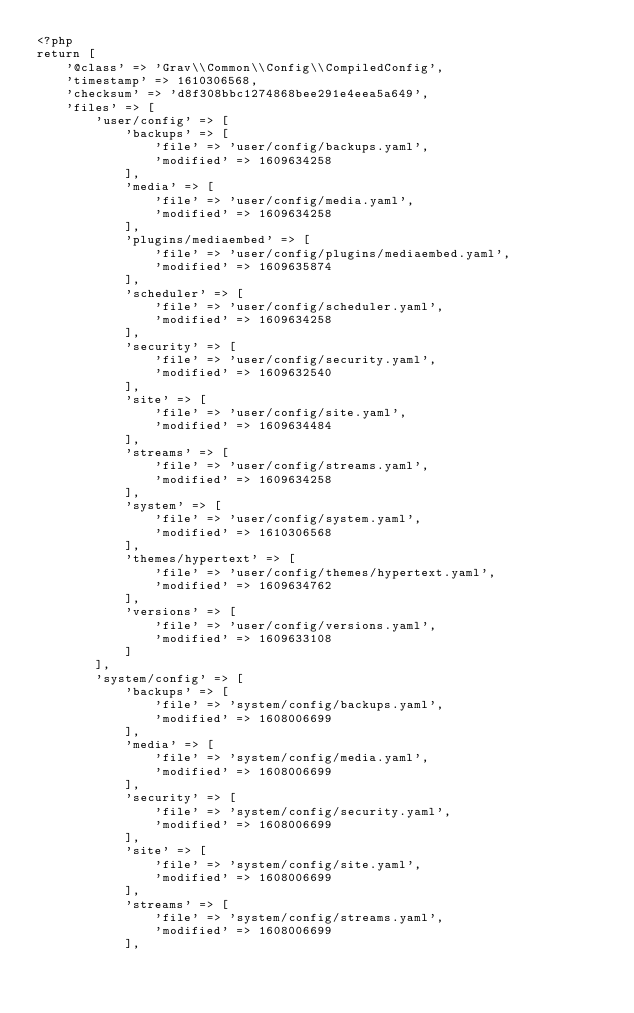Convert code to text. <code><loc_0><loc_0><loc_500><loc_500><_PHP_><?php
return [
    '@class' => 'Grav\\Common\\Config\\CompiledConfig',
    'timestamp' => 1610306568,
    'checksum' => 'd8f308bbc1274868bee291e4eea5a649',
    'files' => [
        'user/config' => [
            'backups' => [
                'file' => 'user/config/backups.yaml',
                'modified' => 1609634258
            ],
            'media' => [
                'file' => 'user/config/media.yaml',
                'modified' => 1609634258
            ],
            'plugins/mediaembed' => [
                'file' => 'user/config/plugins/mediaembed.yaml',
                'modified' => 1609635874
            ],
            'scheduler' => [
                'file' => 'user/config/scheduler.yaml',
                'modified' => 1609634258
            ],
            'security' => [
                'file' => 'user/config/security.yaml',
                'modified' => 1609632540
            ],
            'site' => [
                'file' => 'user/config/site.yaml',
                'modified' => 1609634484
            ],
            'streams' => [
                'file' => 'user/config/streams.yaml',
                'modified' => 1609634258
            ],
            'system' => [
                'file' => 'user/config/system.yaml',
                'modified' => 1610306568
            ],
            'themes/hypertext' => [
                'file' => 'user/config/themes/hypertext.yaml',
                'modified' => 1609634762
            ],
            'versions' => [
                'file' => 'user/config/versions.yaml',
                'modified' => 1609633108
            ]
        ],
        'system/config' => [
            'backups' => [
                'file' => 'system/config/backups.yaml',
                'modified' => 1608006699
            ],
            'media' => [
                'file' => 'system/config/media.yaml',
                'modified' => 1608006699
            ],
            'security' => [
                'file' => 'system/config/security.yaml',
                'modified' => 1608006699
            ],
            'site' => [
                'file' => 'system/config/site.yaml',
                'modified' => 1608006699
            ],
            'streams' => [
                'file' => 'system/config/streams.yaml',
                'modified' => 1608006699
            ],</code> 